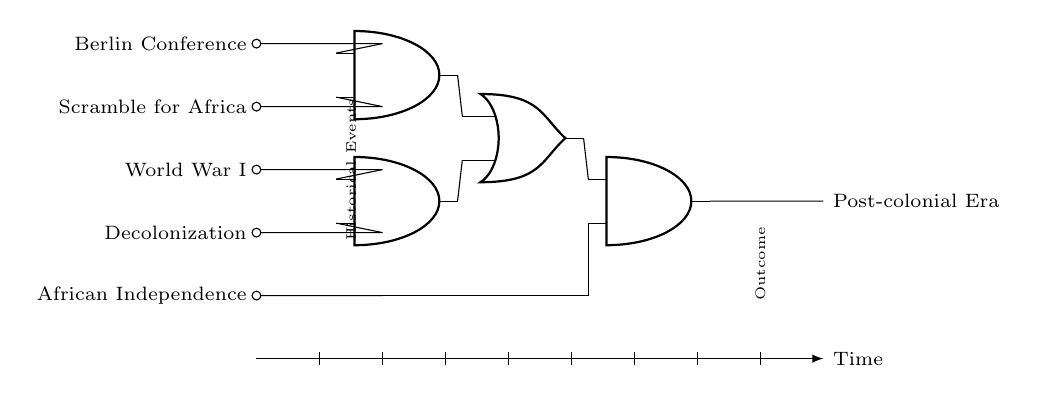What are the inputs to the circuit? The inputs to the circuit are the five historical events listed on the left side: Berlin Conference, Scramble for Africa, World War I, Decolonization, and African Independence.
Answer: Berlin Conference, Scramble for Africa, World War I, Decolonization, African Independence How many AND gates are present in the circuit? There are three AND gates in the circuit, identifiable by their symbol and distribution in the diagram.
Answer: 3 What does the output represent? The output of the circuit represents the "Post-colonial Era," indicated at the right end of the circuit diagram as the final result.
Answer: Post-colonial Era Which historical event is directly connected to the last AND gate? The event that is directly connected to the last AND gate is "African Independence," which connects to the AND gate as the second input.
Answer: African Independence What combination of events activates the first OR gate? The first OR gate is activated by the outputs of the two AND gates connected to the inputs of "Berlin Conference" and "Scramble for Africa" as the first AND gate, and "World War I" and "Decolonization" as the second AND gate.
Answer: Berlin Conference, Scramble for Africa, World War I, Decolonization Explain how the sequence of events flows to the output. The sequence of events flows to the output through a series of logical operations: first, the AND gates process combinations of the input events to produce outputs, which feed into the OR gate. The final AND gate processes inputs from the first AND gate and one direct historical event to produce the post-colonial outcome.
Answer: Through logical AND and OR gate operations 